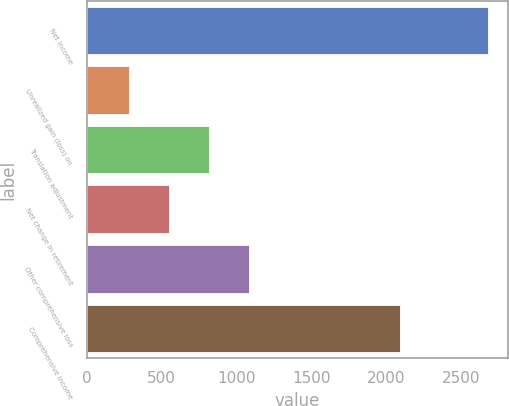<chart> <loc_0><loc_0><loc_500><loc_500><bar_chart><fcel>Net income<fcel>Unrealized gain (loss) on<fcel>Translation adjustment<fcel>Net change in retirement<fcel>Other comprehensive loss<fcel>Comprehensive income<nl><fcel>2675<fcel>285.5<fcel>816.5<fcel>551<fcel>1082<fcel>2088<nl></chart> 